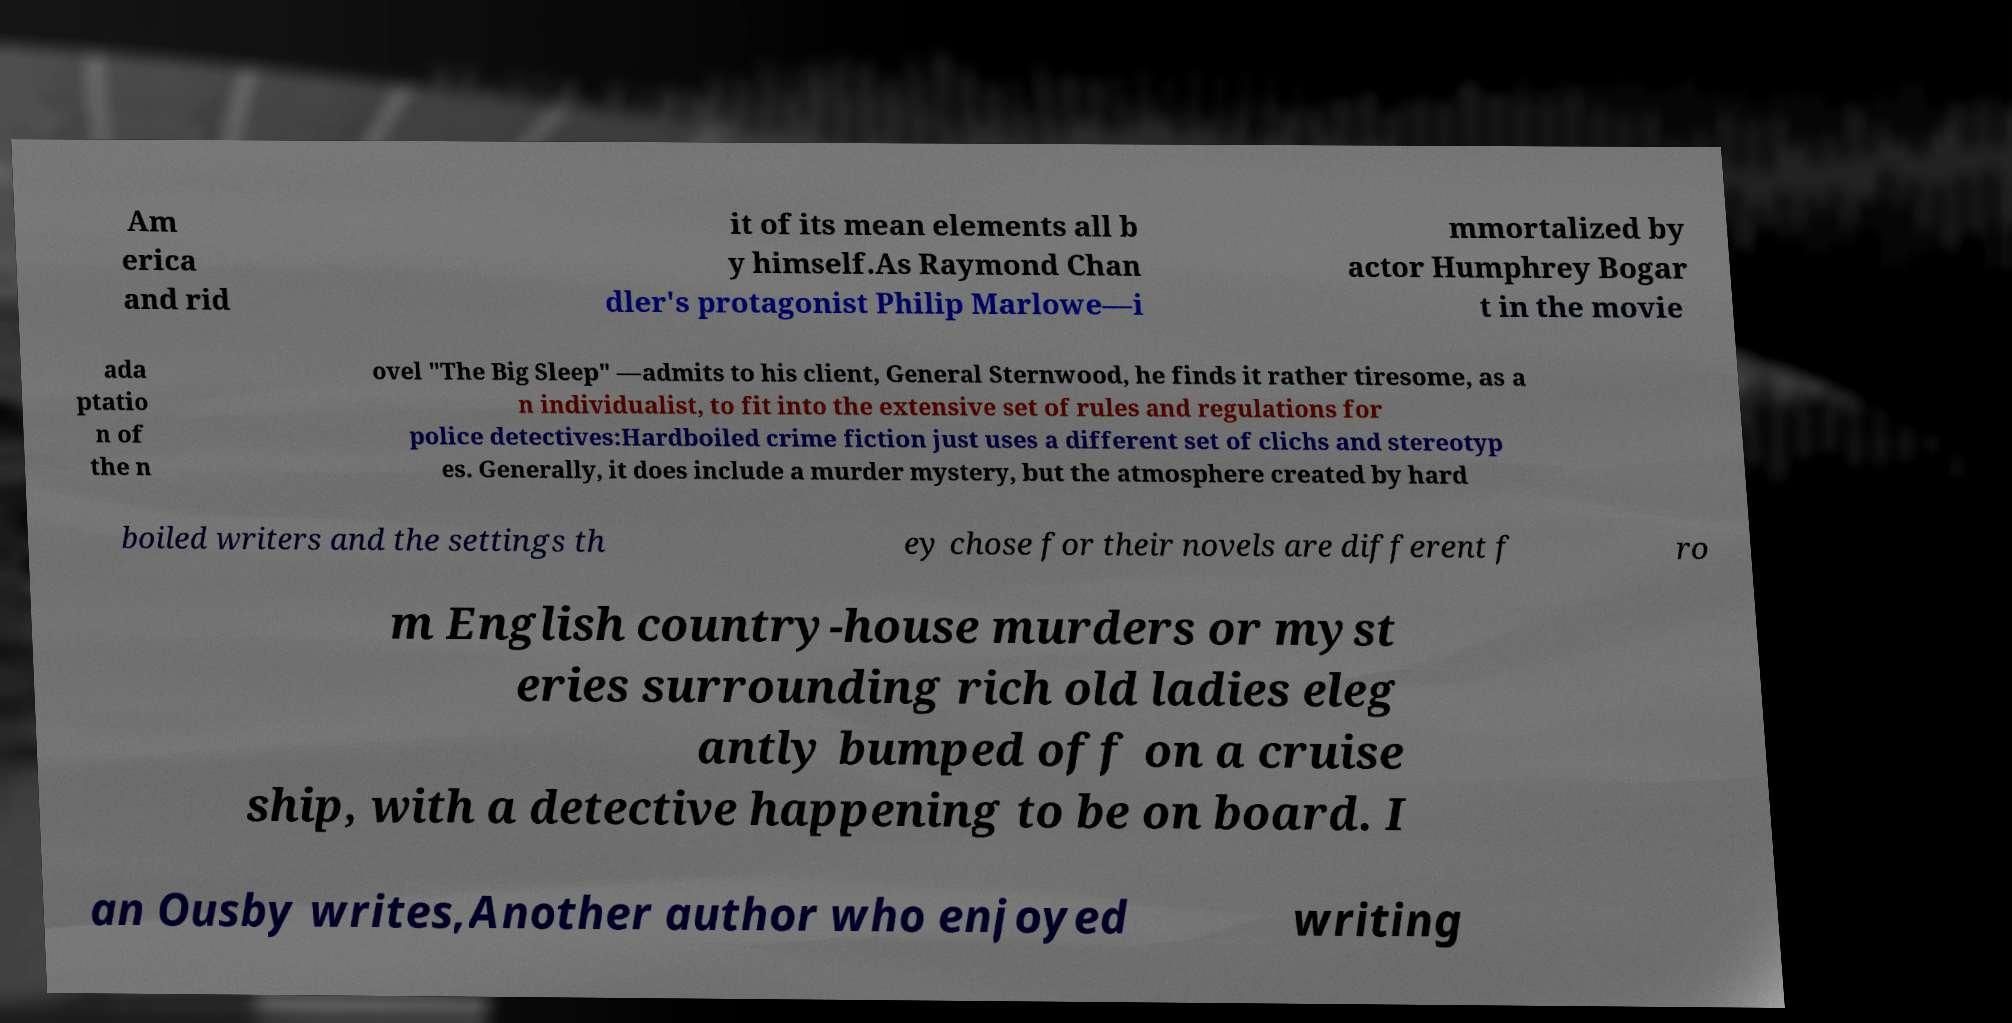What messages or text are displayed in this image? I need them in a readable, typed format. Am erica and rid it of its mean elements all b y himself.As Raymond Chan dler's protagonist Philip Marlowe—i mmortalized by actor Humphrey Bogar t in the movie ada ptatio n of the n ovel "The Big Sleep" —admits to his client, General Sternwood, he finds it rather tiresome, as a n individualist, to fit into the extensive set of rules and regulations for police detectives:Hardboiled crime fiction just uses a different set of clichs and stereotyp es. Generally, it does include a murder mystery, but the atmosphere created by hard boiled writers and the settings th ey chose for their novels are different f ro m English country-house murders or myst eries surrounding rich old ladies eleg antly bumped off on a cruise ship, with a detective happening to be on board. I an Ousby writes,Another author who enjoyed writing 